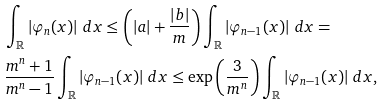Convert formula to latex. <formula><loc_0><loc_0><loc_500><loc_500>& \int _ { \mathbb { R } } \left | \varphi _ { n } ( x ) \right | \, d x \leq \left ( | a | + \frac { | b | } { m } \right ) \int _ { \mathbb { R } } \left | \varphi _ { n - 1 } ( x ) \right | \, d x = \\ & \frac { m ^ { n } + 1 } { m ^ { n } - 1 } \int _ { \mathbb { R } } \left | \varphi _ { n - 1 } ( x ) \right | \, d x \leq \exp \left ( \frac { 3 } { m ^ { n } } \right ) \int _ { \mathbb { R } } \left | \varphi _ { n - 1 } ( x ) \right | \, d x ,</formula> 